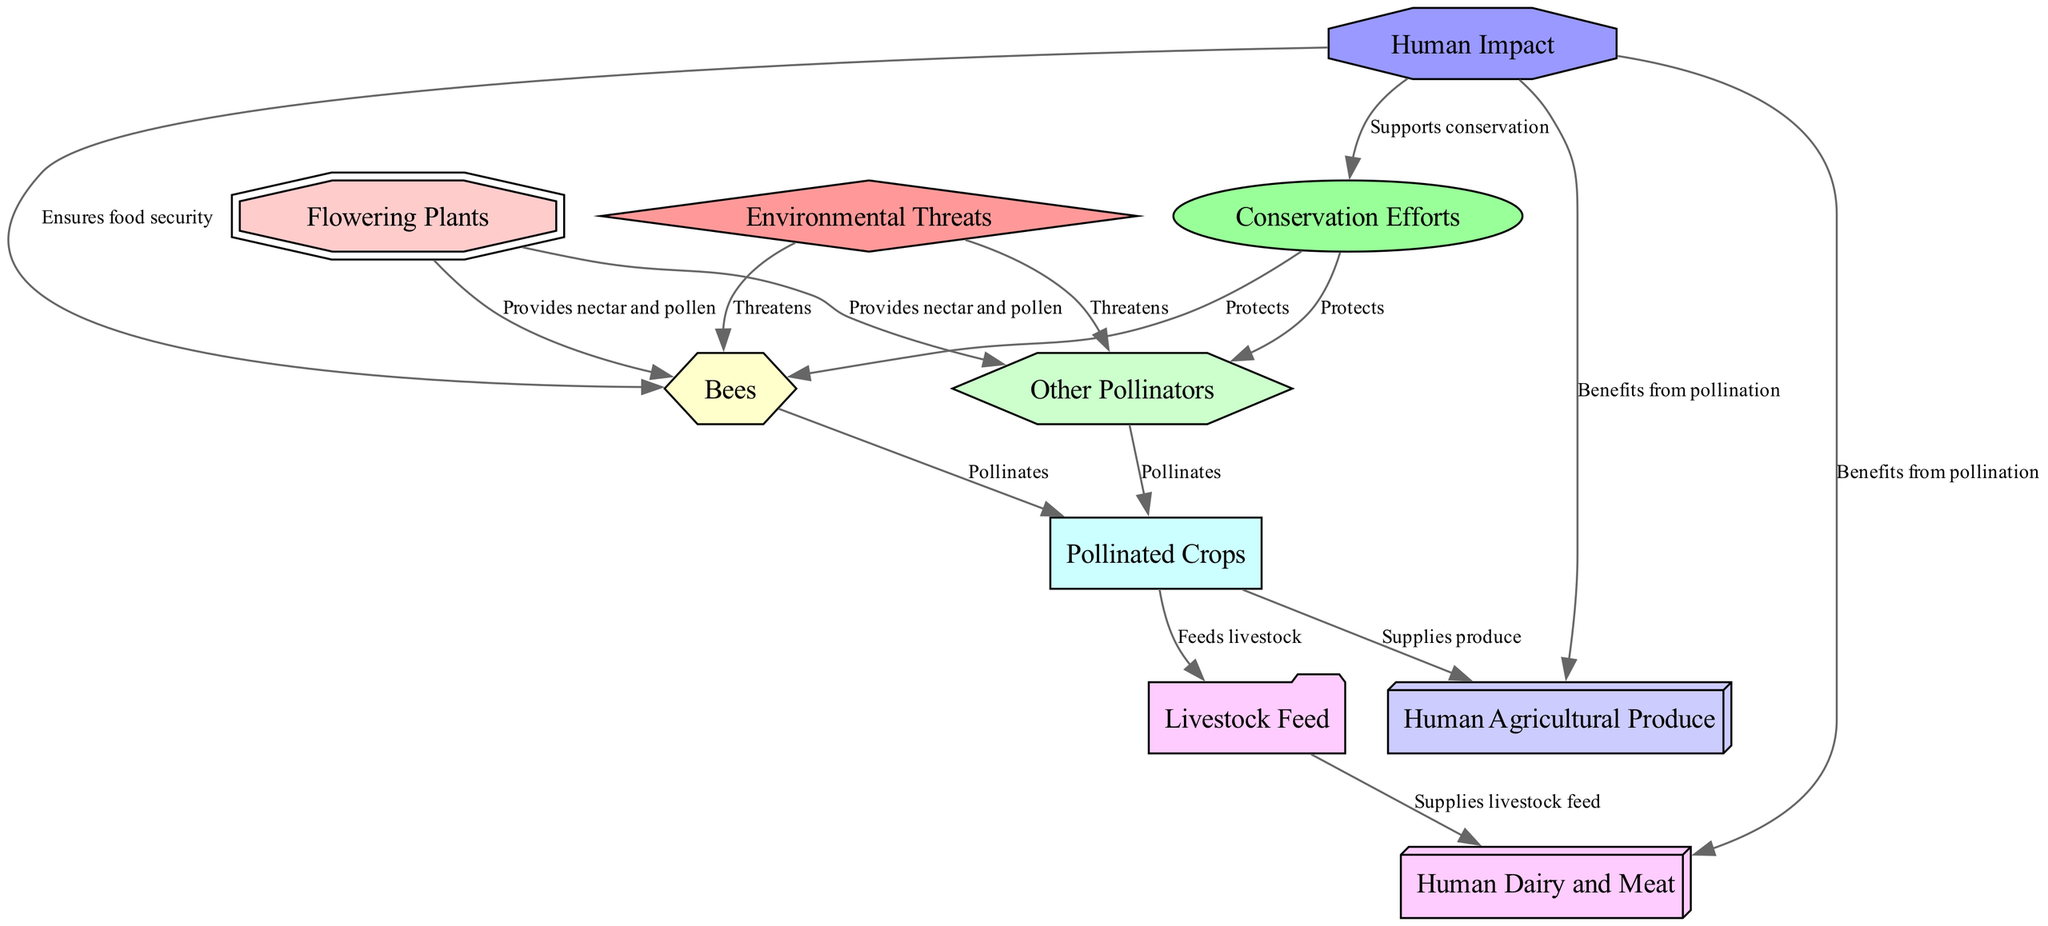What is at the base of the food web? The base of the food web in this diagram is represented by the node "Flowering Plants," which provides nectar and pollen that support the following nodes.
Answer: Flowering Plants How many nodes are in the diagram? The diagram contains ten nodes that represent various components in the food web, including flowering plants, pollinators, and agricultural produce.
Answer: 10 What do bees do in the food web? Bees are primary pollinators and they play a crucial role in the food web by pollinating crops, which enables the production of many food products.
Answer: Pollinates Which entities are threatened by environmental threats? The environmental threats noted in the diagram primarily impact bees and other pollinators, highlighting the adverse effects of pesticides, habitat loss, and climate change on their populations.
Answer: Bees, Other Pollinators What do conservation efforts aim to protect? Conservation efforts are aimed at protecting pollinators, such as bees and other insects, by creating habitats and reducing pesticide use to ensure their survival.
Answer: Pollinators Which type of produce is reliant on pollination according to the diagram? The types of produce that are reliant on pollination are listed as "Pollinated Crops," which includes fruiting vegetables, nuts, and fruits that need pollinators for their growth.
Answer: Pollinated Crops What is the relationship between pollinated crops and human agricultural produce? The relationship shown in the diagram indicates that pollinated crops supply the food products categorized as "Human Agricultural Produce," making them essential for food security.
Answer: Supplies produce How do livestock feed crops relate to pollination? Livestock feed crops, such as alfalfa and clover, are reliant on pollination as indicated in the diagram, showing that these feed crops depend on pollinators for their growth.
Answer: Depend on pollination What role does human impact play in conservation efforts? Human impact plays a supportive role in conservation efforts as depicted in the diagram, illustrating how positive actions can help protect pollinators and ensure food security.
Answer: Supports conservation 